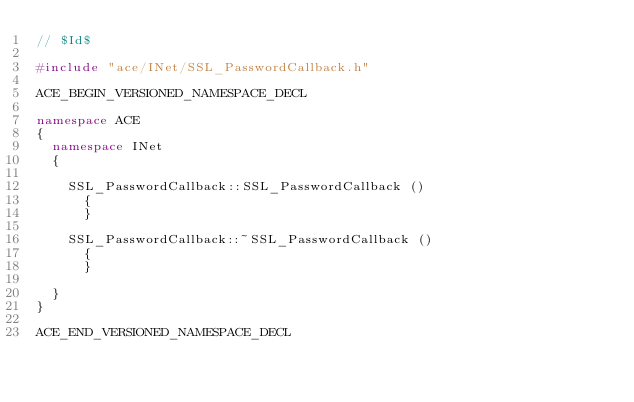Convert code to text. <code><loc_0><loc_0><loc_500><loc_500><_C++_>// $Id$

#include "ace/INet/SSL_PasswordCallback.h"

ACE_BEGIN_VERSIONED_NAMESPACE_DECL

namespace ACE
{
  namespace INet
  {

    SSL_PasswordCallback::SSL_PasswordCallback ()
      {
      }

    SSL_PasswordCallback::~SSL_PasswordCallback ()
      {
      }

  }
}

ACE_END_VERSIONED_NAMESPACE_DECL
</code> 